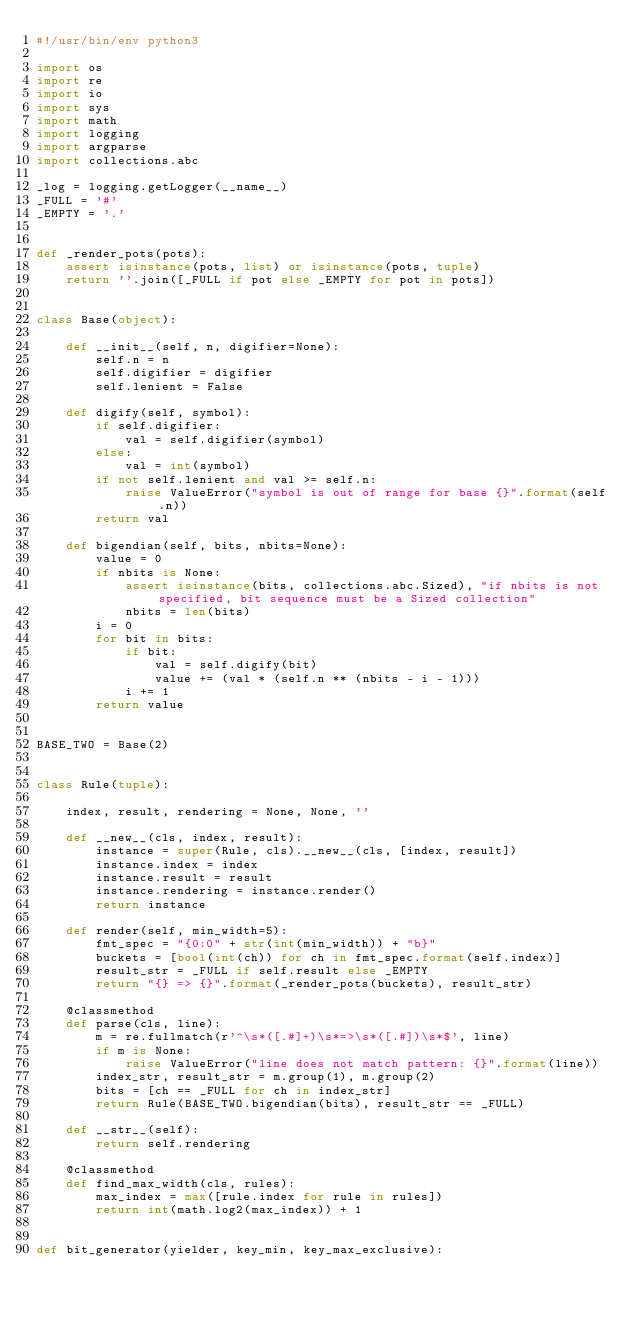<code> <loc_0><loc_0><loc_500><loc_500><_Python_>#!/usr/bin/env python3

import os
import re
import io
import sys
import math
import logging
import argparse
import collections.abc

_log = logging.getLogger(__name__)
_FULL = '#'
_EMPTY = '.'


def _render_pots(pots):
    assert isinstance(pots, list) or isinstance(pots, tuple)
    return ''.join([_FULL if pot else _EMPTY for pot in pots])


class Base(object):

    def __init__(self, n, digifier=None):
        self.n = n
        self.digifier = digifier
        self.lenient = False
    
    def digify(self, symbol):
        if self.digifier:
            val = self.digifier(symbol)
        else:
            val = int(symbol)
        if not self.lenient and val >= self.n:
            raise ValueError("symbol is out of range for base {}".format(self.n))
        return val

    def bigendian(self, bits, nbits=None):
        value = 0
        if nbits is None:
            assert isinstance(bits, collections.abc.Sized), "if nbits is not specified, bit sequence must be a Sized collection"
            nbits = len(bits)
        i = 0
        for bit in bits:
            if bit:
                val = self.digify(bit)
                value += (val * (self.n ** (nbits - i - 1)))
            i += 1
        return value


BASE_TWO = Base(2)


class Rule(tuple):

    index, result, rendering = None, None, ''

    def __new__(cls, index, result):
        instance = super(Rule, cls).__new__(cls, [index, result])
        instance.index = index
        instance.result = result
        instance.rendering = instance.render()
        return instance
    
    def render(self, min_width=5):
        fmt_spec = "{0:0" + str(int(min_width)) + "b}"
        buckets = [bool(int(ch)) for ch in fmt_spec.format(self.index)]
        result_str = _FULL if self.result else _EMPTY
        return "{} => {}".format(_render_pots(buckets), result_str)
    
    @classmethod
    def parse(cls, line):
        m = re.fullmatch(r'^\s*([.#]+)\s*=>\s*([.#])\s*$', line)
        if m is None:
            raise ValueError("line does not match pattern: {}".format(line))
        index_str, result_str = m.group(1), m.group(2)
        bits = [ch == _FULL for ch in index_str]
        return Rule(BASE_TWO.bigendian(bits), result_str == _FULL)
    
    def __str__(self):
        return self.rendering
    
    @classmethod
    def find_max_width(cls, rules):
        max_index = max([rule.index for rule in rules])
        return int(math.log2(max_index)) + 1


def bit_generator(yielder, key_min, key_max_exclusive):</code> 